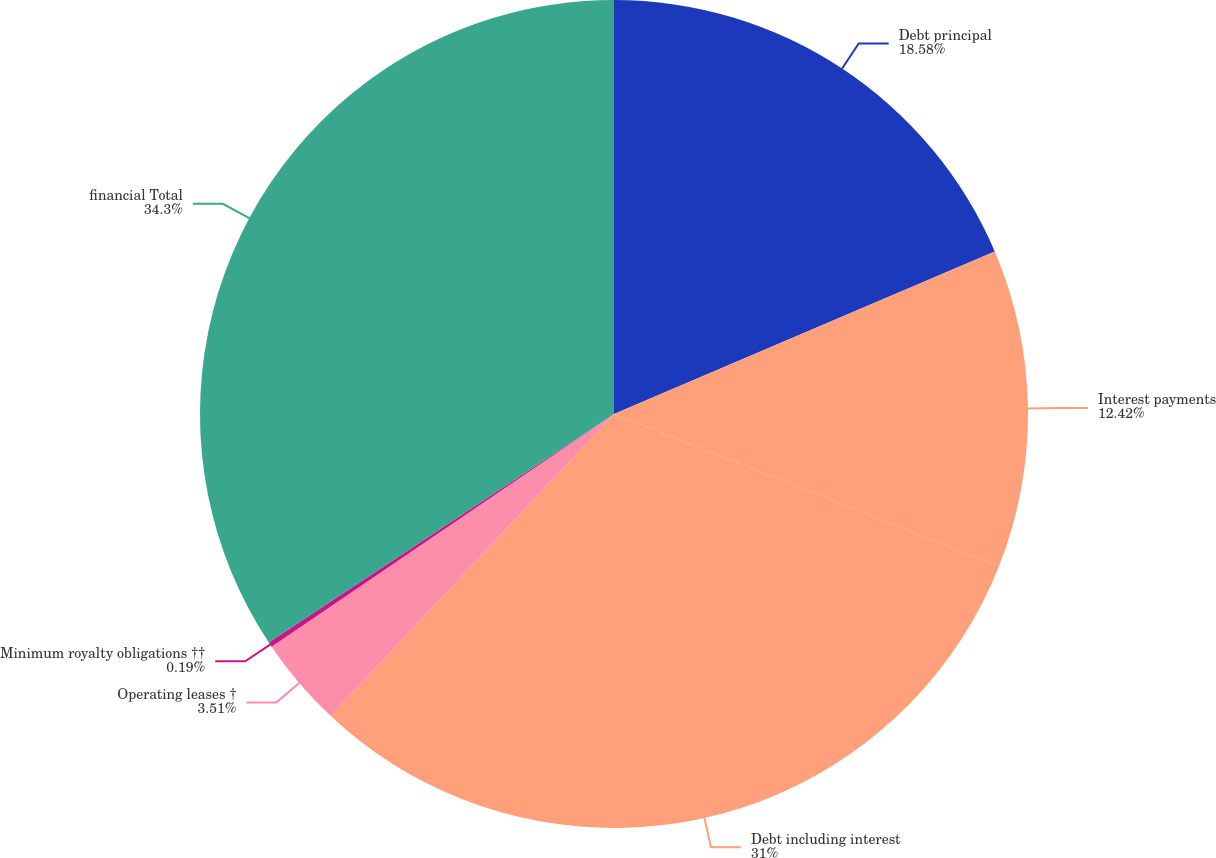Convert chart to OTSL. <chart><loc_0><loc_0><loc_500><loc_500><pie_chart><fcel>Debt principal<fcel>Interest payments<fcel>Debt including interest<fcel>Operating leases †<fcel>Minimum royalty obligations ††<fcel>financial Total<nl><fcel>18.58%<fcel>12.42%<fcel>31.0%<fcel>3.51%<fcel>0.19%<fcel>34.31%<nl></chart> 